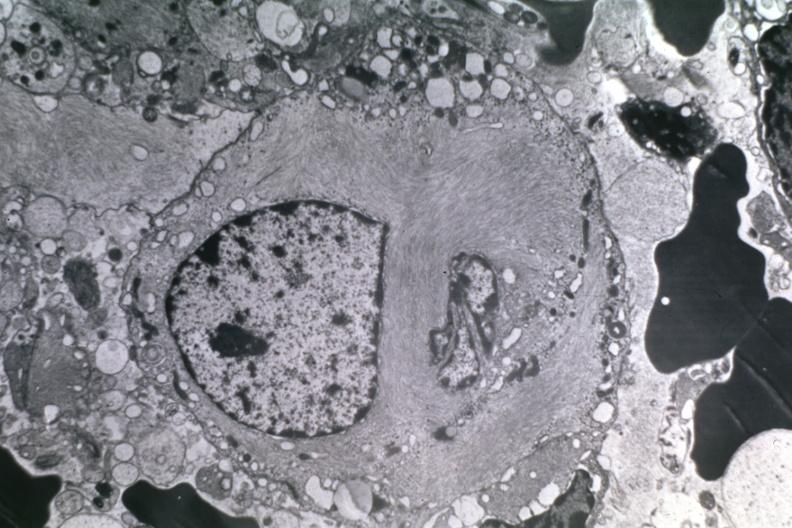what does this image show?
Answer the question using a single word or phrase. Dr garcia tumors 10 